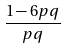<formula> <loc_0><loc_0><loc_500><loc_500>\frac { 1 - 6 p q } { p q }</formula> 